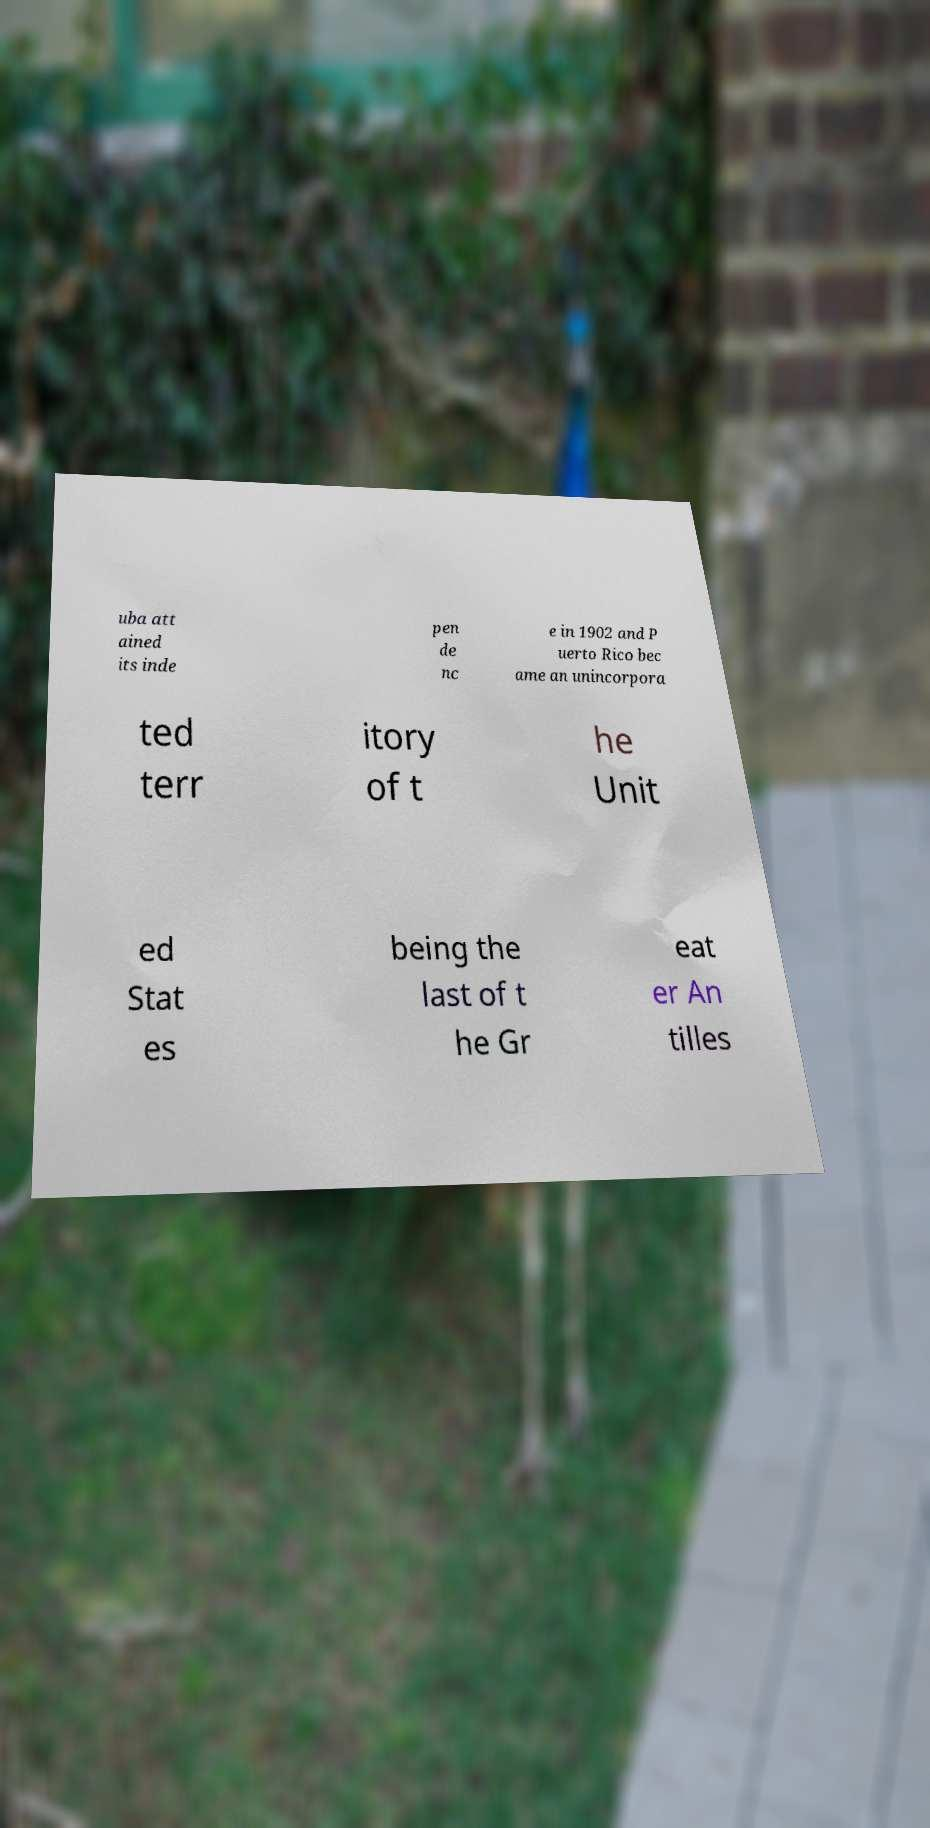Could you extract and type out the text from this image? uba att ained its inde pen de nc e in 1902 and P uerto Rico bec ame an unincorpora ted terr itory of t he Unit ed Stat es being the last of t he Gr eat er An tilles 